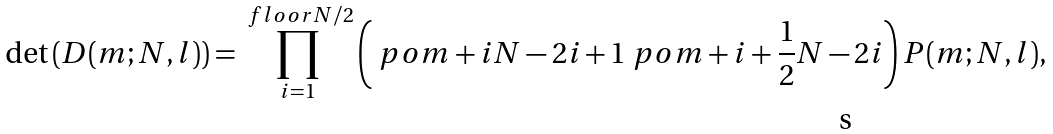<formula> <loc_0><loc_0><loc_500><loc_500>\det \left ( D ( m ; N , l ) \right ) = \prod _ { i = 1 } ^ { \ f l o o r { N / 2 } } \left ( \ p o { m + i } { N - 2 i + 1 } \ p o { m + i + \frac { 1 } { 2 } } { N - 2 i } \right ) P ( m ; N , l ) ,</formula> 